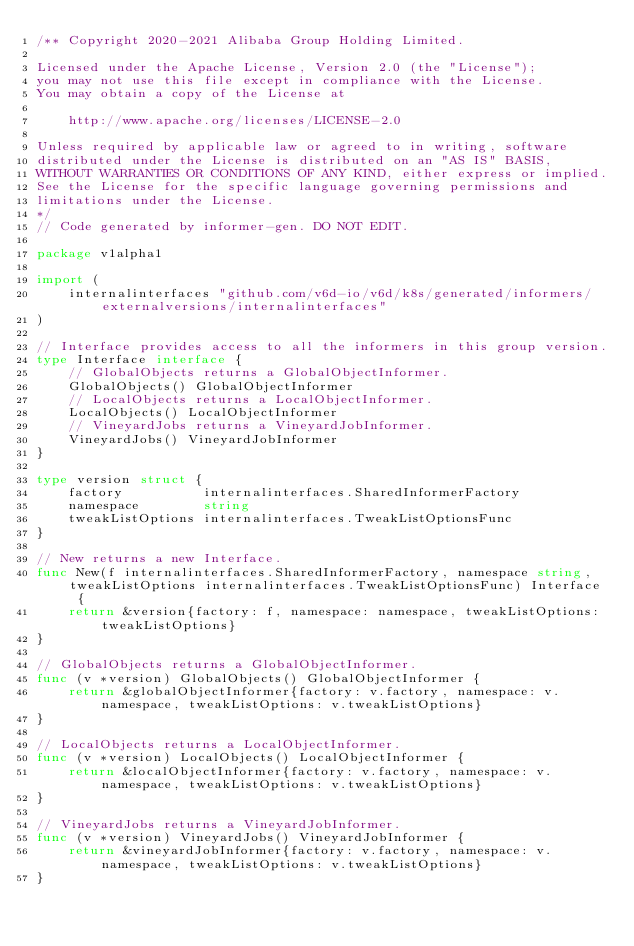<code> <loc_0><loc_0><loc_500><loc_500><_Go_>/** Copyright 2020-2021 Alibaba Group Holding Limited.

Licensed under the Apache License, Version 2.0 (the "License");
you may not use this file except in compliance with the License.
You may obtain a copy of the License at

    http://www.apache.org/licenses/LICENSE-2.0

Unless required by applicable law or agreed to in writing, software
distributed under the License is distributed on an "AS IS" BASIS,
WITHOUT WARRANTIES OR CONDITIONS OF ANY KIND, either express or implied.
See the License for the specific language governing permissions and
limitations under the License.
*/
// Code generated by informer-gen. DO NOT EDIT.

package v1alpha1

import (
	internalinterfaces "github.com/v6d-io/v6d/k8s/generated/informers/externalversions/internalinterfaces"
)

// Interface provides access to all the informers in this group version.
type Interface interface {
	// GlobalObjects returns a GlobalObjectInformer.
	GlobalObjects() GlobalObjectInformer
	// LocalObjects returns a LocalObjectInformer.
	LocalObjects() LocalObjectInformer
	// VineyardJobs returns a VineyardJobInformer.
	VineyardJobs() VineyardJobInformer
}

type version struct {
	factory          internalinterfaces.SharedInformerFactory
	namespace        string
	tweakListOptions internalinterfaces.TweakListOptionsFunc
}

// New returns a new Interface.
func New(f internalinterfaces.SharedInformerFactory, namespace string, tweakListOptions internalinterfaces.TweakListOptionsFunc) Interface {
	return &version{factory: f, namespace: namespace, tweakListOptions: tweakListOptions}
}

// GlobalObjects returns a GlobalObjectInformer.
func (v *version) GlobalObjects() GlobalObjectInformer {
	return &globalObjectInformer{factory: v.factory, namespace: v.namespace, tweakListOptions: v.tweakListOptions}
}

// LocalObjects returns a LocalObjectInformer.
func (v *version) LocalObjects() LocalObjectInformer {
	return &localObjectInformer{factory: v.factory, namespace: v.namespace, tweakListOptions: v.tweakListOptions}
}

// VineyardJobs returns a VineyardJobInformer.
func (v *version) VineyardJobs() VineyardJobInformer {
	return &vineyardJobInformer{factory: v.factory, namespace: v.namespace, tweakListOptions: v.tweakListOptions}
}
</code> 